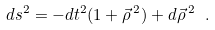Convert formula to latex. <formula><loc_0><loc_0><loc_500><loc_500>d s ^ { 2 } = - d t ^ { 2 } ( 1 + \vec { \rho } { \, } ^ { 2 } ) + d \vec { \rho } { \, } ^ { 2 } \ .</formula> 